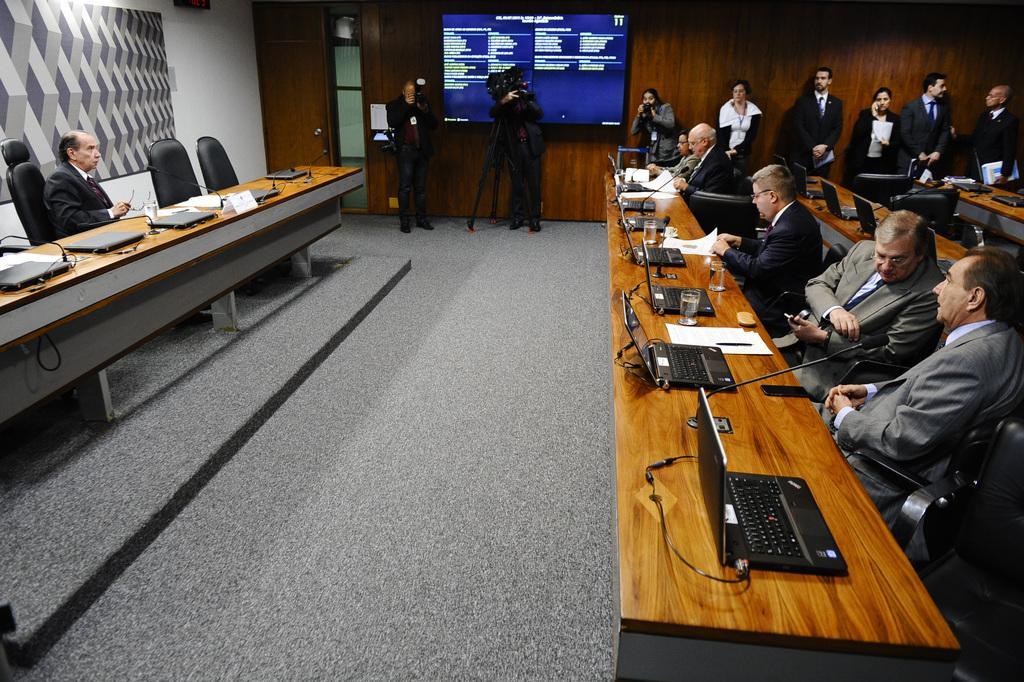Can you describe this image briefly? In this image there are people, tables, board, screen, door, camera, camera stand, wooden wall and objects. On the table there are laptops, mics, glasses, papers and objects. Among them few people are standing, few people are sitting on chairs and few people are holding objects. Screen and board are on the walls. Something is written on the screen.   